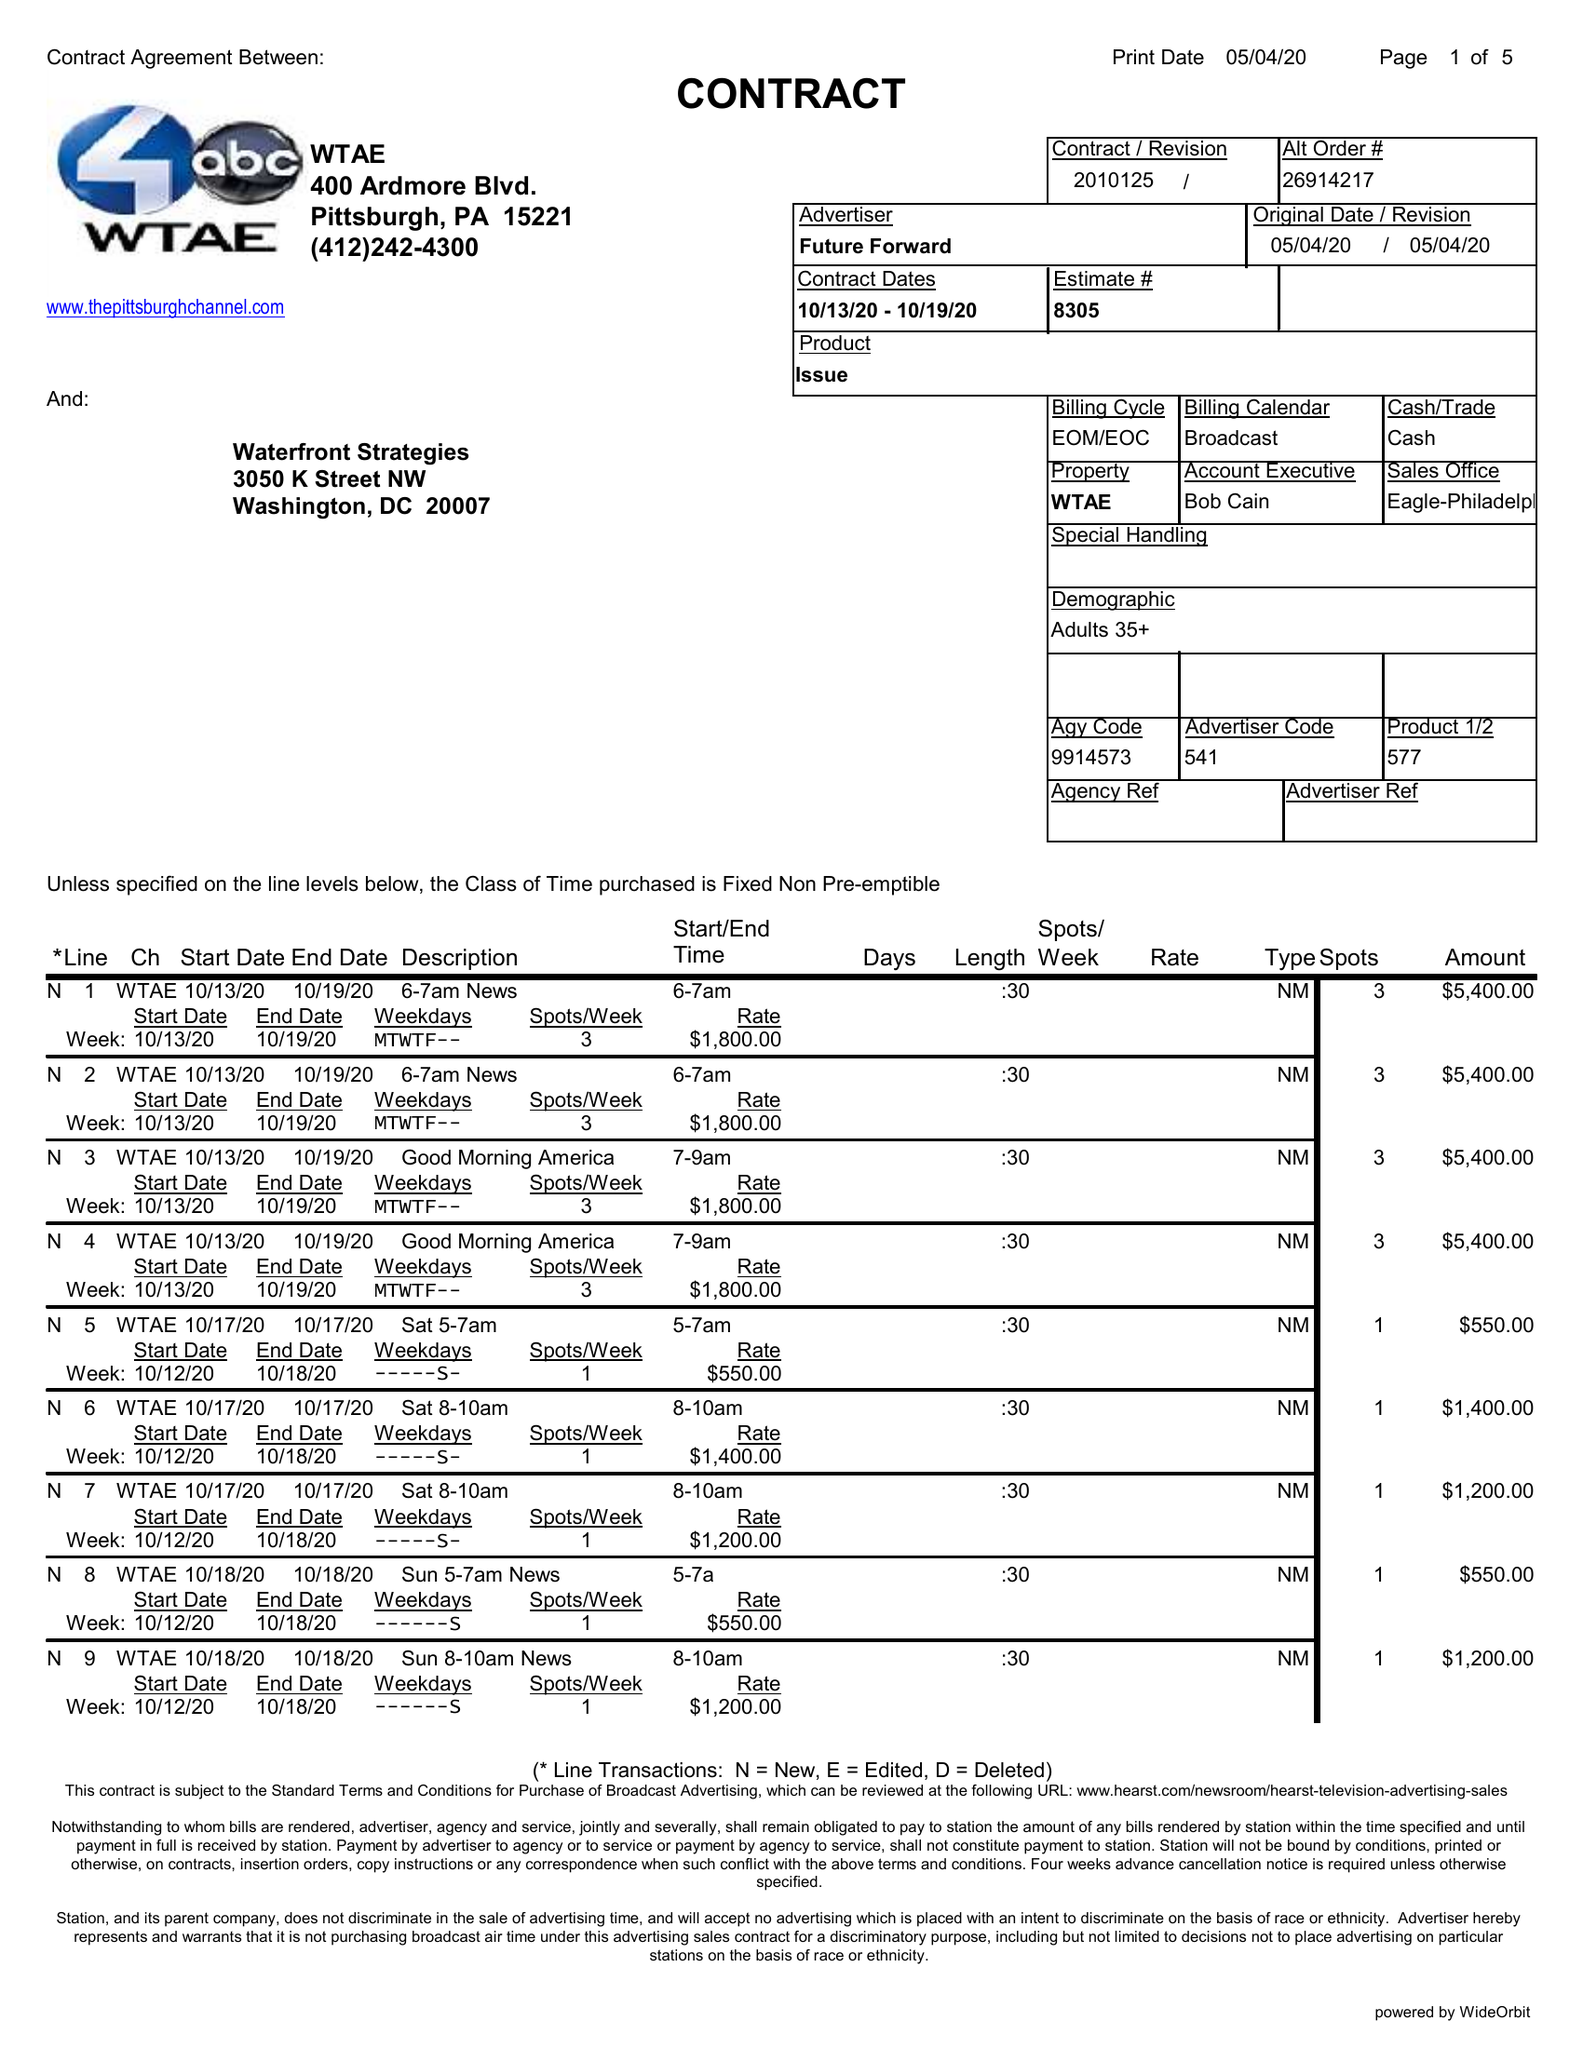What is the value for the flight_to?
Answer the question using a single word or phrase. 10/19/20 